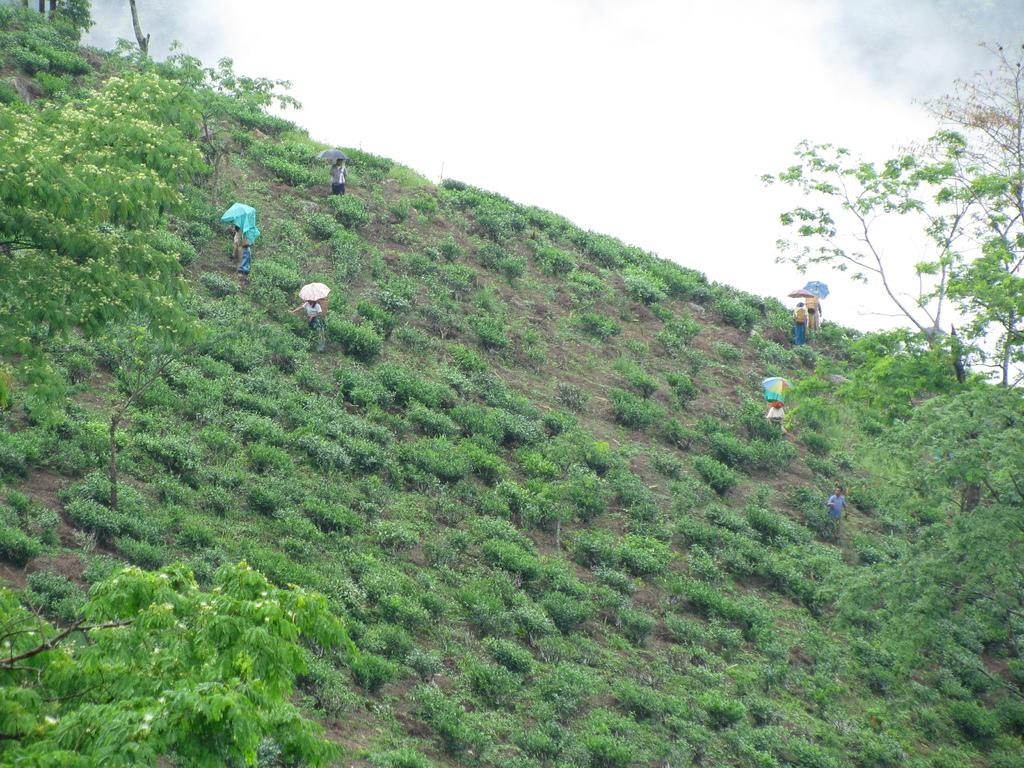Who or what can be seen in the image? There are people in the image. Where are the people located? The people are on the grass. What are the people holding in the image? The people are holding umbrellas. What type of vegetation is visible in the image? There are trees in the image. What is visible at the top of the image? The sky is visible at the top of the image. What type of berry can be seen growing on the sofa in the image? There is no sofa or berry present in the image. What thought is the person in the image having? The image does not provide information about the thoughts of the people in the image. 